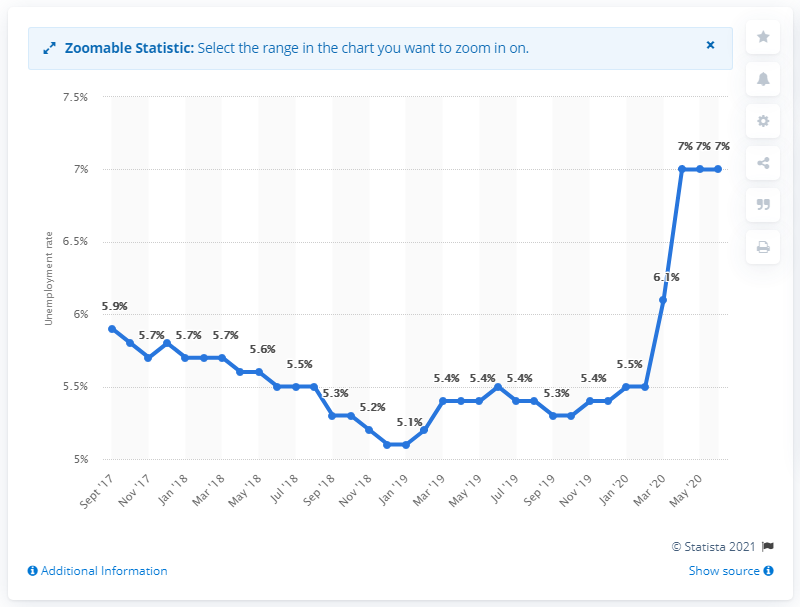Indicate a few pertinent items in this graphic. The forecast for the unemployment rate in Luxembourg in 2021 is that it will decrease to 6.1%. 